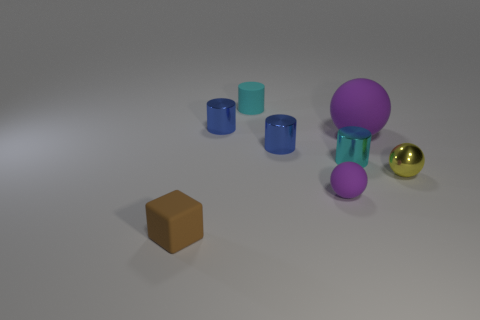Add 2 big red cylinders. How many objects exist? 10 Subtract all spheres. How many objects are left? 5 Add 4 yellow metal balls. How many yellow metal balls are left? 5 Add 5 large purple spheres. How many large purple spheres exist? 6 Subtract 0 cyan spheres. How many objects are left? 8 Subtract all cyan things. Subtract all matte things. How many objects are left? 2 